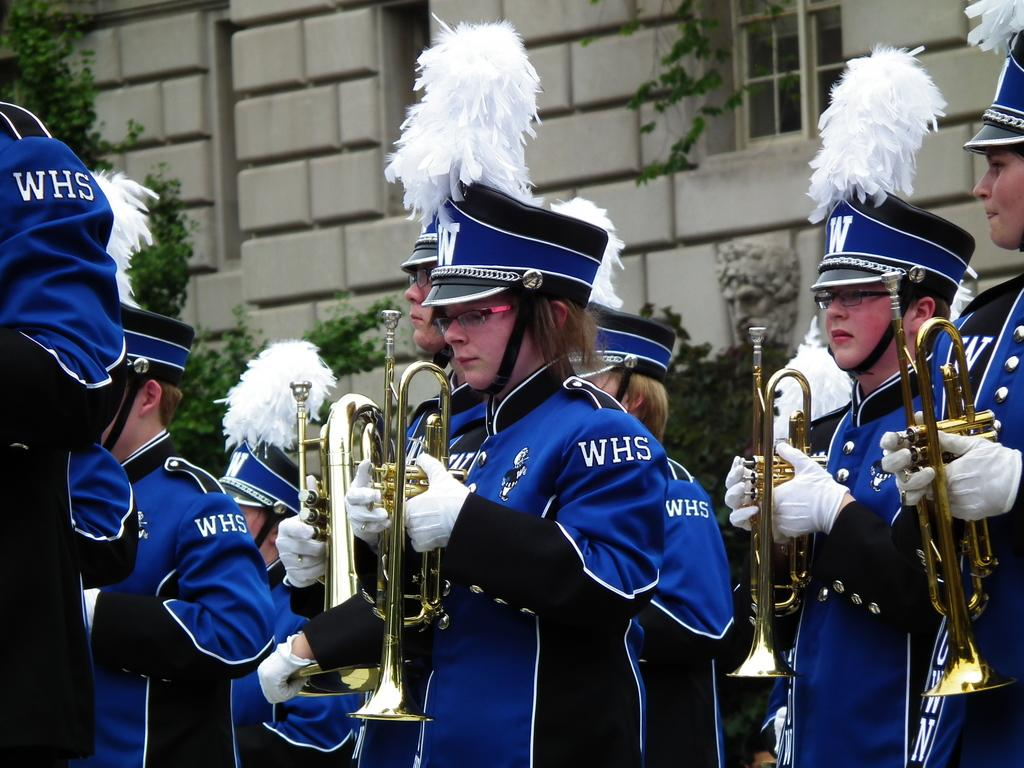What are the people in the image doing? The people in the image are holding musical instruments. What else can be seen in the image besides the people with instruments? There are plants and a sculpture in the image. Is there any architectural feature visible in the image? Yes, there is a window on a wall in the image. What type of plastic object can be seen being pulled by the people in the image? There is no plastic object being pulled by the people in the image. 